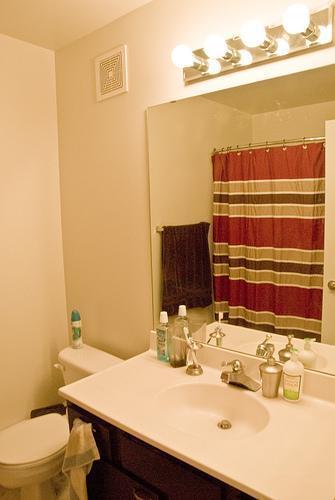How many lights are visible?
Give a very brief answer. 4. 